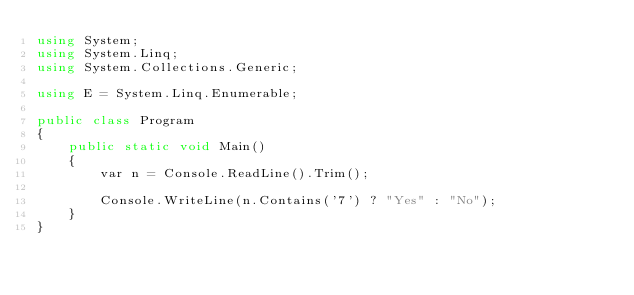Convert code to text. <code><loc_0><loc_0><loc_500><loc_500><_C#_>using System;
using System.Linq;
using System.Collections.Generic;

using E = System.Linq.Enumerable;

public class Program
{
    public static void Main()
    {
        var n = Console.ReadLine().Trim();

        Console.WriteLine(n.Contains('7') ? "Yes" : "No");
    }
}
</code> 